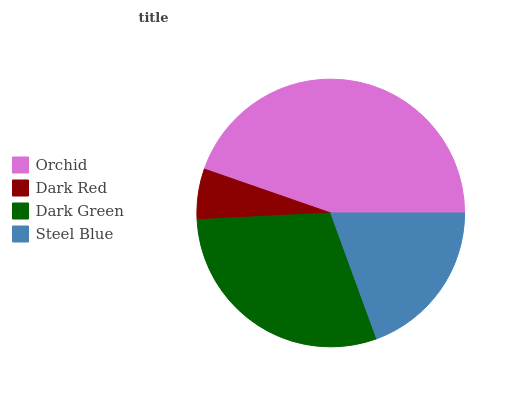Is Dark Red the minimum?
Answer yes or no. Yes. Is Orchid the maximum?
Answer yes or no. Yes. Is Dark Green the minimum?
Answer yes or no. No. Is Dark Green the maximum?
Answer yes or no. No. Is Dark Green greater than Dark Red?
Answer yes or no. Yes. Is Dark Red less than Dark Green?
Answer yes or no. Yes. Is Dark Red greater than Dark Green?
Answer yes or no. No. Is Dark Green less than Dark Red?
Answer yes or no. No. Is Dark Green the high median?
Answer yes or no. Yes. Is Steel Blue the low median?
Answer yes or no. Yes. Is Orchid the high median?
Answer yes or no. No. Is Orchid the low median?
Answer yes or no. No. 